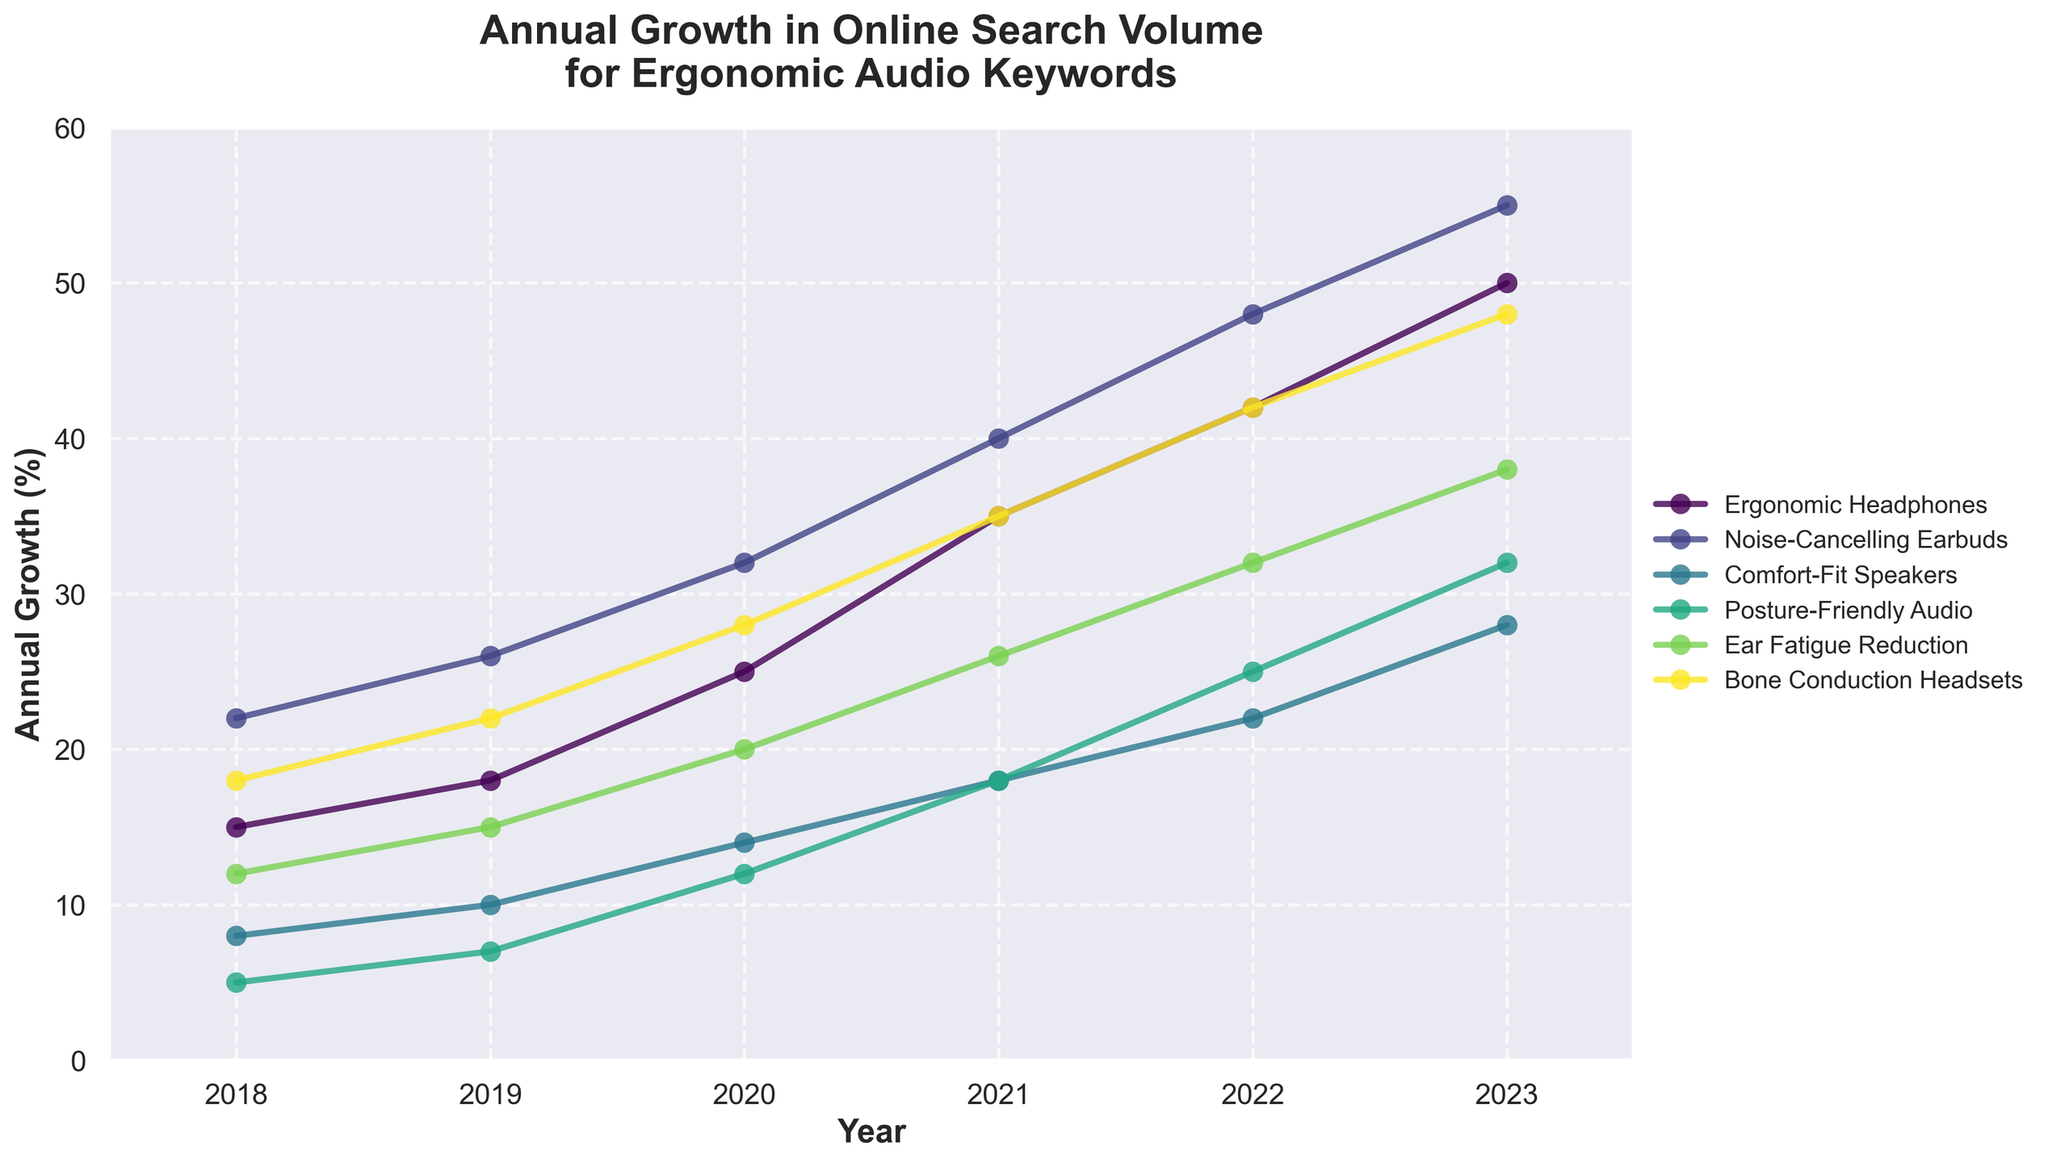What was the growth percentage for Noise-Cancelling Earbuds in 2021? Look at the point corresponding to 2021 on the line representing Noise-Cancelling Earbuds. The growth percentage is labeled as 40%.
Answer: 40% Which keyword had the highest growth percentage in 2023? Observe the endpoints of the lines for 2023. The highest point corresponds to Noise-Cancelling Earbuds, indicating the highest growth percentage of 55%.
Answer: Noise-Cancelling Earbuds What is the difference in growth percentage between Ergonomic Headphones and Ear Fatigue Reduction in 2022? Find the values for Ergonomic Headphones and Ear Fatigue Reduction in 2022: Ergonomic Headphones = 42%, Ear Fatigue Reduction = 32%. Subtract the latter from the former: 42% - 32% = 10%.
Answer: 10% Which keyword experienced the most consistent growth over the years? Assess the lines' smoothness and steadiness in upward direction over the years. Ergonomic Headphones and Noise-Cancelling Earbuds both show a consistent upward trend, but Noise-Cancelling Earbuds appear slightly smoother.
Answer: Noise-Cancelling Earbuds What’s the average annual growth percentage for Bone Conduction Headsets from 2018 to 2023? Calculate the sum of the growth percentages from 2018 to 2023 for Bone Conduction Headsets: 18 + 22 + 28 + 35 + 42 + 48 = 193%. Divide by the number of years (6): 193 / 6 ≈ 32.17%.
Answer: 32.17% Between 2019 and 2020, which keyword showed the greatest absolute increase in growth percentage? Find the growth percentages for each keyword in 2019 and 2020 and calculate the differences: Ergonomic Headphones: 25% - 18% = 7%, Noise-Cancelling Earbuds: 32% - 26% = 6%, Comfort-Fit Speakers: 14% - 10% = 4%, Posture-Friendly Audio: 12% - 7% = 5%, Ear Fatigue Reduction: 20% - 15% = 5%, Bone Conduction Headsets: 28% - 22% = 6%. The highest increase is for Ergonomic Headphones at 7%.
Answer: Ergonomic Headphones In which year did Comfort-Fit Speakers experience its highest yearly growth percentage? Examine the line representing Comfort-Fit Speakers and identify the year with the highest data point. It occurs in 2023 with a growth percentage of 28%.
Answer: 2023 How did the growth percentage of Posture-Friendly Audio in 2020 compare to its growth percentage in 2018? Look at the growth percentage of Posture-Friendly Audio in 2020 (12%) and compare it to that in 2018 (5%). The growth in 2020 is more than double.
Answer: More than double Are there any keywords where the growth percentage decreased or stayed constant over the years shown in the data? Check the trend lines for each keyword from 2018 to 2023. All lines are consistently upward, indicating that there are no decreases or constant segments.
Answer: No 